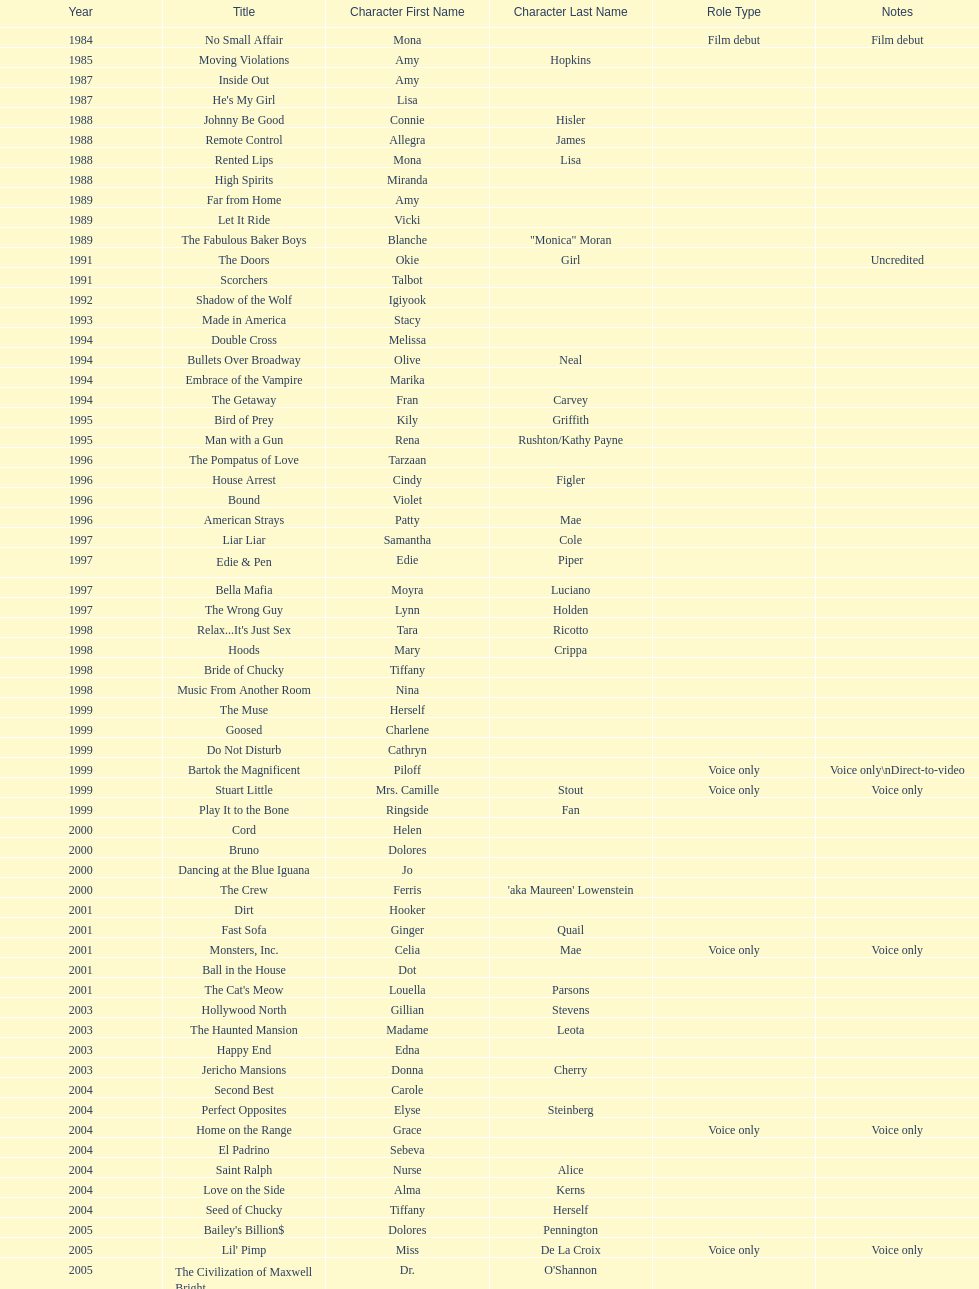How many films does jennifer tilly do a voice over role in? 5. 